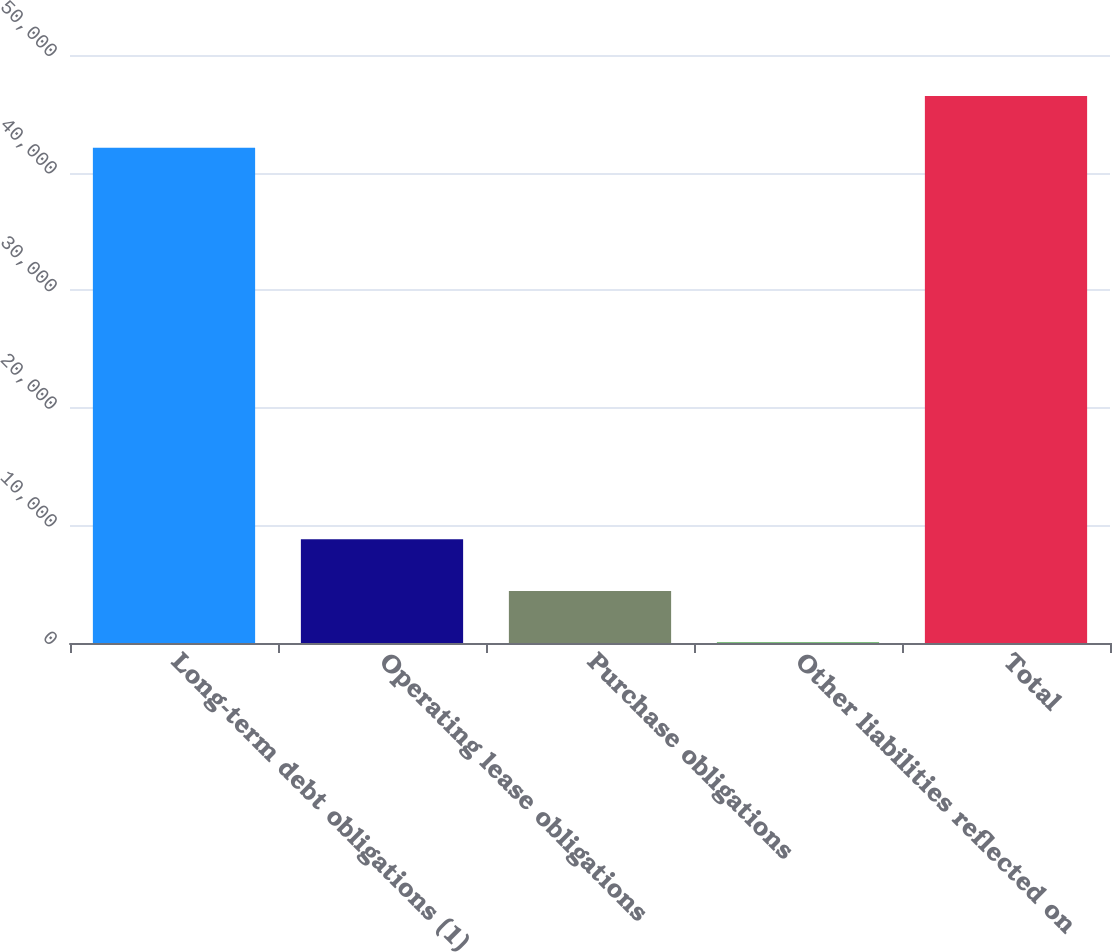Convert chart to OTSL. <chart><loc_0><loc_0><loc_500><loc_500><bar_chart><fcel>Long-term debt obligations (1)<fcel>Operating lease obligations<fcel>Purchase obligations<fcel>Other liabilities reflected on<fcel>Total<nl><fcel>42112<fcel>8824.2<fcel>4429.6<fcel>35<fcel>46506.6<nl></chart> 